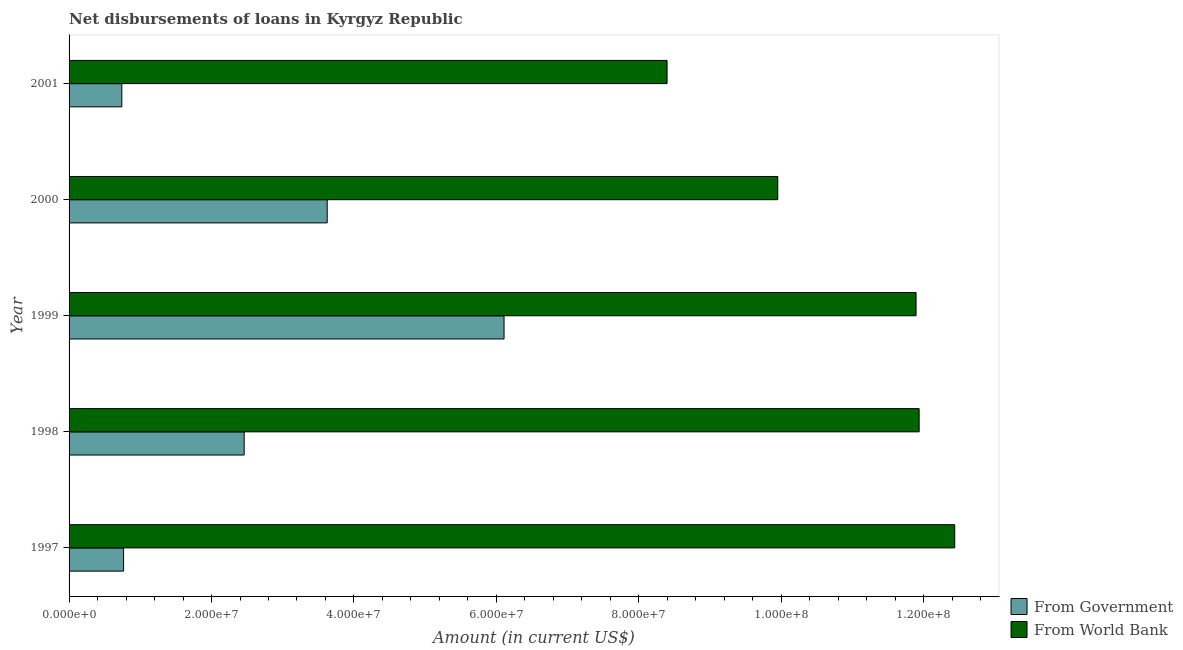How many groups of bars are there?
Offer a very short reply. 5. Are the number of bars per tick equal to the number of legend labels?
Ensure brevity in your answer.  Yes. What is the label of the 2nd group of bars from the top?
Provide a succinct answer. 2000. What is the net disbursements of loan from world bank in 1997?
Your answer should be very brief. 1.24e+08. Across all years, what is the maximum net disbursements of loan from government?
Offer a terse response. 6.11e+07. Across all years, what is the minimum net disbursements of loan from world bank?
Ensure brevity in your answer.  8.40e+07. In which year was the net disbursements of loan from government minimum?
Your response must be concise. 2001. What is the total net disbursements of loan from world bank in the graph?
Offer a very short reply. 5.46e+08. What is the difference between the net disbursements of loan from world bank in 1999 and that in 2001?
Make the answer very short. 3.50e+07. What is the difference between the net disbursements of loan from government in 2000 and the net disbursements of loan from world bank in 1999?
Offer a very short reply. -8.27e+07. What is the average net disbursements of loan from government per year?
Offer a terse response. 2.74e+07. In the year 1997, what is the difference between the net disbursements of loan from world bank and net disbursements of loan from government?
Offer a very short reply. 1.17e+08. In how many years, is the net disbursements of loan from world bank greater than 28000000 US$?
Provide a succinct answer. 5. What is the ratio of the net disbursements of loan from world bank in 1998 to that in 2000?
Offer a very short reply. 1.2. What is the difference between the highest and the second highest net disbursements of loan from world bank?
Your answer should be very brief. 5.00e+06. What is the difference between the highest and the lowest net disbursements of loan from world bank?
Your response must be concise. 4.04e+07. In how many years, is the net disbursements of loan from world bank greater than the average net disbursements of loan from world bank taken over all years?
Give a very brief answer. 3. What does the 1st bar from the top in 1999 represents?
Your answer should be compact. From World Bank. What does the 2nd bar from the bottom in 1999 represents?
Offer a very short reply. From World Bank. Are all the bars in the graph horizontal?
Your answer should be compact. Yes. How many years are there in the graph?
Ensure brevity in your answer.  5. What is the difference between two consecutive major ticks on the X-axis?
Offer a very short reply. 2.00e+07. Are the values on the major ticks of X-axis written in scientific E-notation?
Give a very brief answer. Yes. What is the title of the graph?
Make the answer very short. Net disbursements of loans in Kyrgyz Republic. Does "Money lenders" appear as one of the legend labels in the graph?
Offer a very short reply. No. What is the label or title of the X-axis?
Your answer should be compact. Amount (in current US$). What is the label or title of the Y-axis?
Ensure brevity in your answer.  Year. What is the Amount (in current US$) of From Government in 1997?
Provide a succinct answer. 7.65e+06. What is the Amount (in current US$) in From World Bank in 1997?
Make the answer very short. 1.24e+08. What is the Amount (in current US$) in From Government in 1998?
Your response must be concise. 2.46e+07. What is the Amount (in current US$) in From World Bank in 1998?
Your answer should be compact. 1.19e+08. What is the Amount (in current US$) in From Government in 1999?
Give a very brief answer. 6.11e+07. What is the Amount (in current US$) of From World Bank in 1999?
Provide a short and direct response. 1.19e+08. What is the Amount (in current US$) of From Government in 2000?
Give a very brief answer. 3.62e+07. What is the Amount (in current US$) of From World Bank in 2000?
Provide a short and direct response. 9.95e+07. What is the Amount (in current US$) of From Government in 2001?
Ensure brevity in your answer.  7.41e+06. What is the Amount (in current US$) of From World Bank in 2001?
Ensure brevity in your answer.  8.40e+07. Across all years, what is the maximum Amount (in current US$) of From Government?
Provide a short and direct response. 6.11e+07. Across all years, what is the maximum Amount (in current US$) in From World Bank?
Give a very brief answer. 1.24e+08. Across all years, what is the minimum Amount (in current US$) of From Government?
Ensure brevity in your answer.  7.41e+06. Across all years, what is the minimum Amount (in current US$) of From World Bank?
Your answer should be compact. 8.40e+07. What is the total Amount (in current US$) in From Government in the graph?
Provide a succinct answer. 1.37e+08. What is the total Amount (in current US$) of From World Bank in the graph?
Give a very brief answer. 5.46e+08. What is the difference between the Amount (in current US$) in From Government in 1997 and that in 1998?
Give a very brief answer. -1.69e+07. What is the difference between the Amount (in current US$) of From World Bank in 1997 and that in 1998?
Provide a short and direct response. 5.00e+06. What is the difference between the Amount (in current US$) of From Government in 1997 and that in 1999?
Your response must be concise. -5.34e+07. What is the difference between the Amount (in current US$) in From World Bank in 1997 and that in 1999?
Provide a succinct answer. 5.43e+06. What is the difference between the Amount (in current US$) of From Government in 1997 and that in 2000?
Make the answer very short. -2.86e+07. What is the difference between the Amount (in current US$) of From World Bank in 1997 and that in 2000?
Your answer should be compact. 2.48e+07. What is the difference between the Amount (in current US$) of From Government in 1997 and that in 2001?
Your answer should be compact. 2.47e+05. What is the difference between the Amount (in current US$) in From World Bank in 1997 and that in 2001?
Make the answer very short. 4.04e+07. What is the difference between the Amount (in current US$) of From Government in 1998 and that in 1999?
Ensure brevity in your answer.  -3.65e+07. What is the difference between the Amount (in current US$) in From World Bank in 1998 and that in 1999?
Your response must be concise. 4.34e+05. What is the difference between the Amount (in current US$) in From Government in 1998 and that in 2000?
Your answer should be compact. -1.17e+07. What is the difference between the Amount (in current US$) of From World Bank in 1998 and that in 2000?
Keep it short and to the point. 1.98e+07. What is the difference between the Amount (in current US$) of From Government in 1998 and that in 2001?
Your answer should be very brief. 1.72e+07. What is the difference between the Amount (in current US$) in From World Bank in 1998 and that in 2001?
Your answer should be compact. 3.54e+07. What is the difference between the Amount (in current US$) of From Government in 1999 and that in 2000?
Provide a short and direct response. 2.48e+07. What is the difference between the Amount (in current US$) of From World Bank in 1999 and that in 2000?
Offer a very short reply. 1.94e+07. What is the difference between the Amount (in current US$) in From Government in 1999 and that in 2001?
Keep it short and to the point. 5.37e+07. What is the difference between the Amount (in current US$) of From World Bank in 1999 and that in 2001?
Offer a terse response. 3.50e+07. What is the difference between the Amount (in current US$) of From Government in 2000 and that in 2001?
Your answer should be compact. 2.88e+07. What is the difference between the Amount (in current US$) in From World Bank in 2000 and that in 2001?
Keep it short and to the point. 1.55e+07. What is the difference between the Amount (in current US$) in From Government in 1997 and the Amount (in current US$) in From World Bank in 1998?
Your answer should be very brief. -1.12e+08. What is the difference between the Amount (in current US$) in From Government in 1997 and the Amount (in current US$) in From World Bank in 1999?
Your answer should be very brief. -1.11e+08. What is the difference between the Amount (in current US$) of From Government in 1997 and the Amount (in current US$) of From World Bank in 2000?
Provide a succinct answer. -9.19e+07. What is the difference between the Amount (in current US$) in From Government in 1997 and the Amount (in current US$) in From World Bank in 2001?
Ensure brevity in your answer.  -7.63e+07. What is the difference between the Amount (in current US$) in From Government in 1998 and the Amount (in current US$) in From World Bank in 1999?
Provide a short and direct response. -9.43e+07. What is the difference between the Amount (in current US$) of From Government in 1998 and the Amount (in current US$) of From World Bank in 2000?
Provide a short and direct response. -7.49e+07. What is the difference between the Amount (in current US$) of From Government in 1998 and the Amount (in current US$) of From World Bank in 2001?
Offer a very short reply. -5.94e+07. What is the difference between the Amount (in current US$) in From Government in 1999 and the Amount (in current US$) in From World Bank in 2000?
Make the answer very short. -3.84e+07. What is the difference between the Amount (in current US$) of From Government in 1999 and the Amount (in current US$) of From World Bank in 2001?
Keep it short and to the point. -2.29e+07. What is the difference between the Amount (in current US$) of From Government in 2000 and the Amount (in current US$) of From World Bank in 2001?
Provide a succinct answer. -4.77e+07. What is the average Amount (in current US$) of From Government per year?
Provide a short and direct response. 2.74e+07. What is the average Amount (in current US$) of From World Bank per year?
Your answer should be very brief. 1.09e+08. In the year 1997, what is the difference between the Amount (in current US$) of From Government and Amount (in current US$) of From World Bank?
Offer a terse response. -1.17e+08. In the year 1998, what is the difference between the Amount (in current US$) in From Government and Amount (in current US$) in From World Bank?
Provide a succinct answer. -9.48e+07. In the year 1999, what is the difference between the Amount (in current US$) in From Government and Amount (in current US$) in From World Bank?
Make the answer very short. -5.79e+07. In the year 2000, what is the difference between the Amount (in current US$) in From Government and Amount (in current US$) in From World Bank?
Your answer should be compact. -6.33e+07. In the year 2001, what is the difference between the Amount (in current US$) of From Government and Amount (in current US$) of From World Bank?
Your answer should be very brief. -7.66e+07. What is the ratio of the Amount (in current US$) in From Government in 1997 to that in 1998?
Your answer should be compact. 0.31. What is the ratio of the Amount (in current US$) in From World Bank in 1997 to that in 1998?
Keep it short and to the point. 1.04. What is the ratio of the Amount (in current US$) in From Government in 1997 to that in 1999?
Your answer should be very brief. 0.13. What is the ratio of the Amount (in current US$) in From World Bank in 1997 to that in 1999?
Make the answer very short. 1.05. What is the ratio of the Amount (in current US$) of From Government in 1997 to that in 2000?
Provide a succinct answer. 0.21. What is the ratio of the Amount (in current US$) in From World Bank in 1997 to that in 2000?
Provide a succinct answer. 1.25. What is the ratio of the Amount (in current US$) of From Government in 1997 to that in 2001?
Ensure brevity in your answer.  1.03. What is the ratio of the Amount (in current US$) in From World Bank in 1997 to that in 2001?
Your answer should be compact. 1.48. What is the ratio of the Amount (in current US$) of From Government in 1998 to that in 1999?
Ensure brevity in your answer.  0.4. What is the ratio of the Amount (in current US$) in From Government in 1998 to that in 2000?
Give a very brief answer. 0.68. What is the ratio of the Amount (in current US$) of From World Bank in 1998 to that in 2000?
Keep it short and to the point. 1.2. What is the ratio of the Amount (in current US$) in From Government in 1998 to that in 2001?
Ensure brevity in your answer.  3.32. What is the ratio of the Amount (in current US$) in From World Bank in 1998 to that in 2001?
Ensure brevity in your answer.  1.42. What is the ratio of the Amount (in current US$) in From Government in 1999 to that in 2000?
Keep it short and to the point. 1.69. What is the ratio of the Amount (in current US$) in From World Bank in 1999 to that in 2000?
Give a very brief answer. 1.2. What is the ratio of the Amount (in current US$) in From Government in 1999 to that in 2001?
Provide a succinct answer. 8.25. What is the ratio of the Amount (in current US$) of From World Bank in 1999 to that in 2001?
Ensure brevity in your answer.  1.42. What is the ratio of the Amount (in current US$) of From Government in 2000 to that in 2001?
Provide a succinct answer. 4.89. What is the ratio of the Amount (in current US$) of From World Bank in 2000 to that in 2001?
Your answer should be compact. 1.19. What is the difference between the highest and the second highest Amount (in current US$) of From Government?
Your answer should be compact. 2.48e+07. What is the difference between the highest and the second highest Amount (in current US$) of From World Bank?
Offer a very short reply. 5.00e+06. What is the difference between the highest and the lowest Amount (in current US$) in From Government?
Provide a short and direct response. 5.37e+07. What is the difference between the highest and the lowest Amount (in current US$) of From World Bank?
Your answer should be compact. 4.04e+07. 